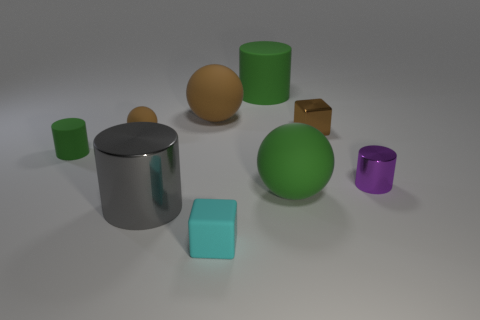How many green cylinders must be subtracted to get 1 green cylinders? 1 Subtract 1 cubes. How many cubes are left? 1 Subtract all brown spheres. How many spheres are left? 1 Subtract all tiny green cylinders. How many cylinders are left? 3 Subtract all cubes. How many objects are left? 7 Subtract all small cylinders. Subtract all metallic objects. How many objects are left? 4 Add 5 purple metallic cylinders. How many purple metallic cylinders are left? 6 Add 8 cyan metal cylinders. How many cyan metal cylinders exist? 8 Subtract 0 gray balls. How many objects are left? 9 Subtract all gray balls. Subtract all yellow cylinders. How many balls are left? 3 